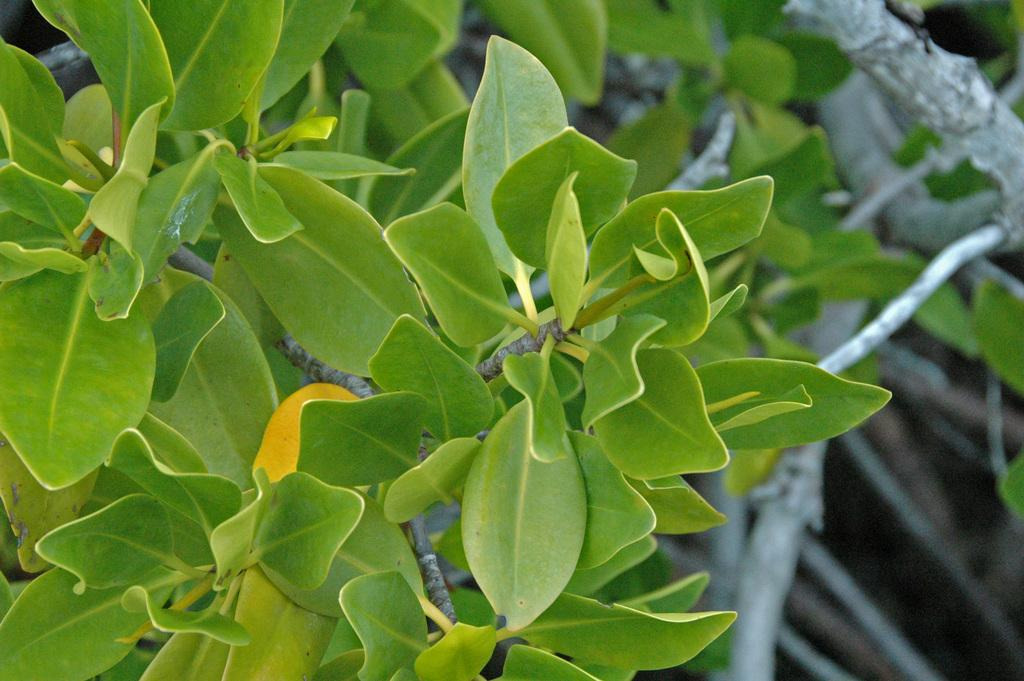What type of vegetation is on the left side of the image? There are green plants on the left side of the image. Is there a basketball game happening in the image? There is no basketball game or any reference to sports in the image; it only features green plants on the left side. 